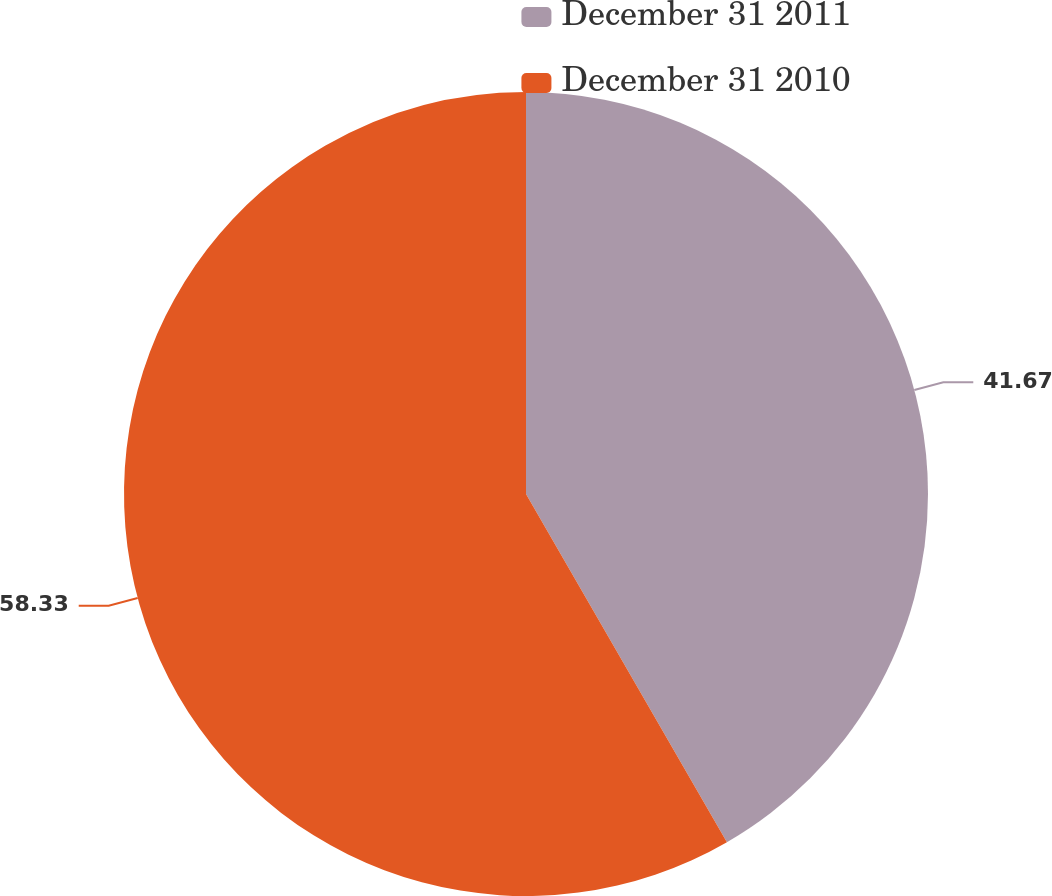<chart> <loc_0><loc_0><loc_500><loc_500><pie_chart><fcel>December 31 2011<fcel>December 31 2010<nl><fcel>41.67%<fcel>58.33%<nl></chart> 